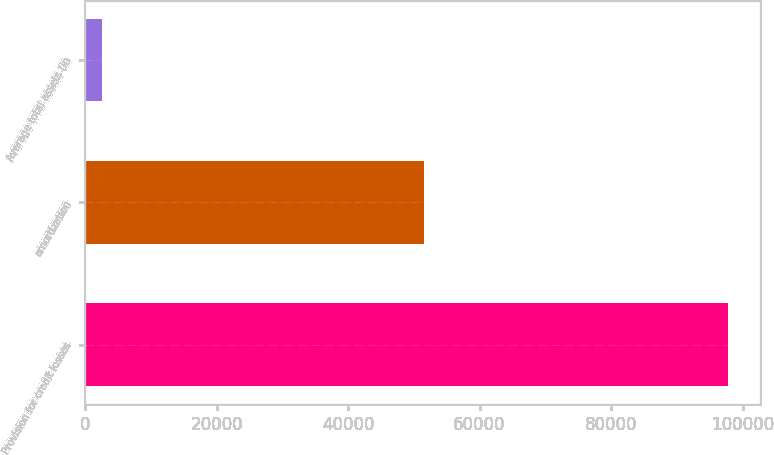Convert chart. <chart><loc_0><loc_0><loc_500><loc_500><bar_chart><fcel>Provision for credit losses<fcel>amortization<fcel>Average total assets (in<nl><fcel>97816<fcel>51552<fcel>2552<nl></chart> 